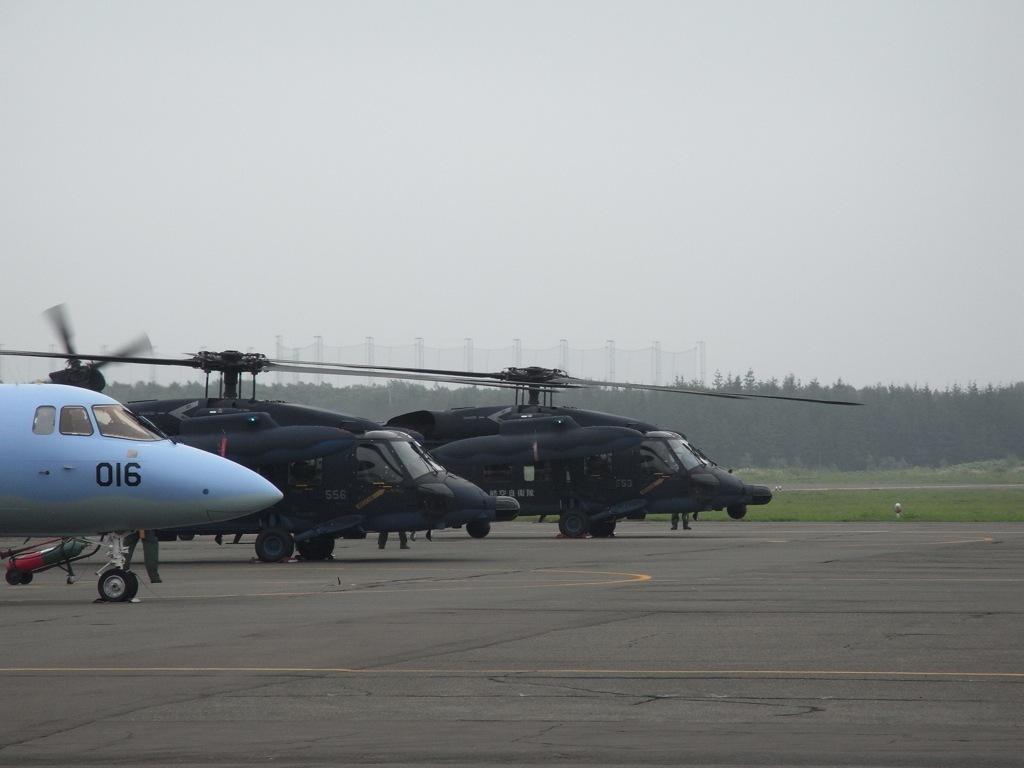How would you summarize this image in a sentence or two? In this image, we can see helicopters on the road and there are people. In the background, there are trees. At the top, there is sky. 